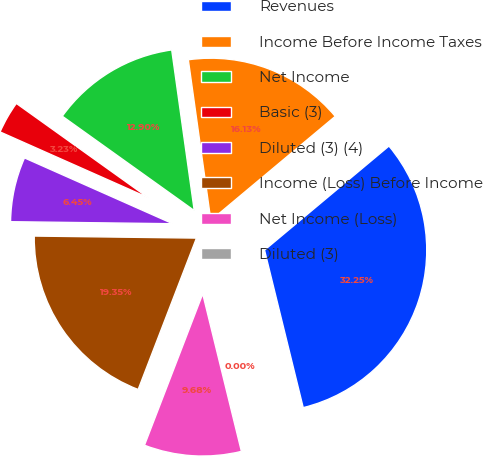Convert chart. <chart><loc_0><loc_0><loc_500><loc_500><pie_chart><fcel>Revenues<fcel>Income Before Income Taxes<fcel>Net Income<fcel>Basic (3)<fcel>Diluted (3) (4)<fcel>Income (Loss) Before Income<fcel>Net Income (Loss)<fcel>Diluted (3)<nl><fcel>32.25%<fcel>16.13%<fcel>12.9%<fcel>3.23%<fcel>6.45%<fcel>19.35%<fcel>9.68%<fcel>0.0%<nl></chart> 